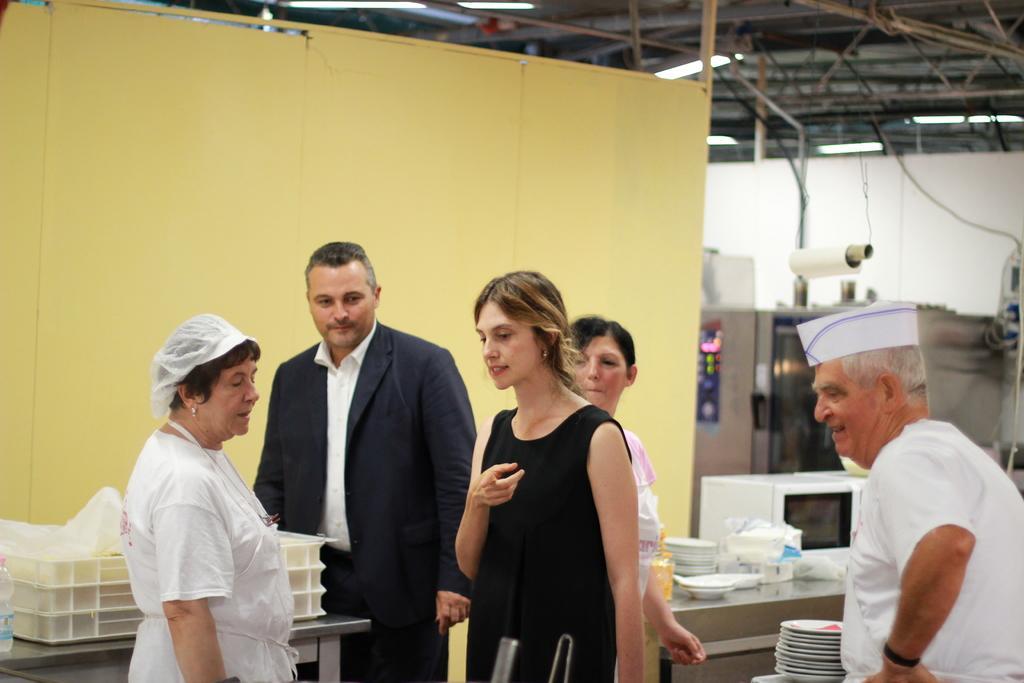How would you summarize this image in a sentence or two? This picture describes about group of people, on the right side of the image we can see a man, he wore a cap, in front of them we can see few plates, trays, microwave oven and other things on the tables, in the background we can see few lights and metal rods. 